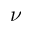<formula> <loc_0><loc_0><loc_500><loc_500>\nu</formula> 